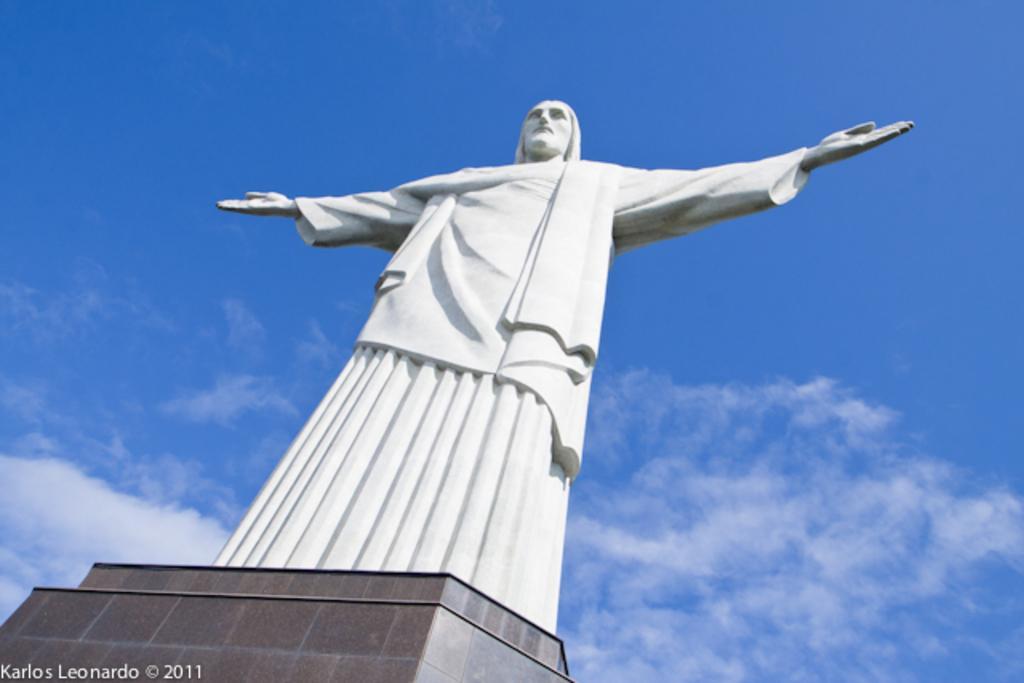Please provide a concise description of this image. In this image there is a sculpture of a man on a pillar. In the background there is the sky. In the bottom left there is text on the image. 